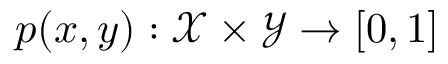Convert formula to latex. <formula><loc_0><loc_0><loc_500><loc_500>p ( x , y ) \colon \mathcal { X } \times \mathcal { Y } \rightarrow [ 0 , 1 ]</formula> 